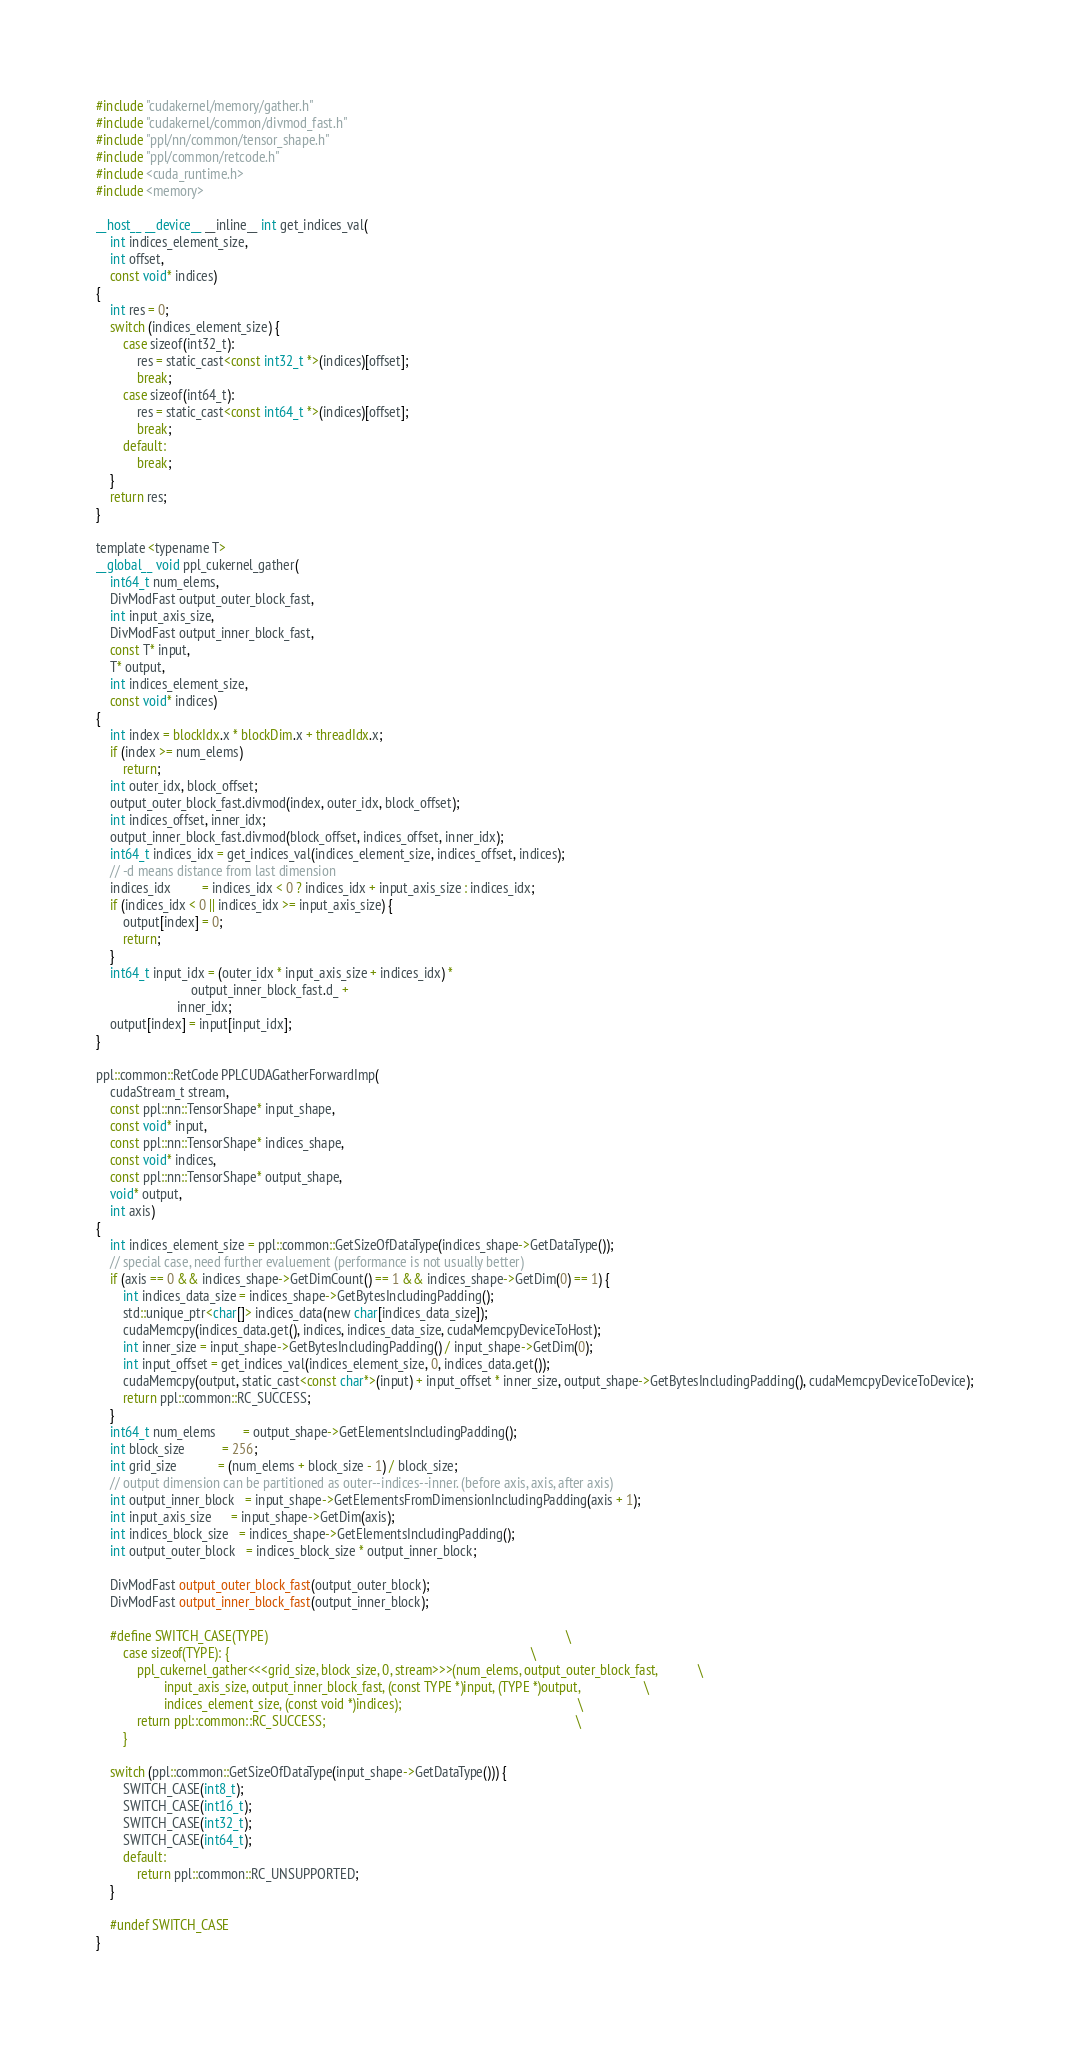<code> <loc_0><loc_0><loc_500><loc_500><_Cuda_>#include "cudakernel/memory/gather.h"
#include "cudakernel/common/divmod_fast.h"
#include "ppl/nn/common/tensor_shape.h"
#include "ppl/common/retcode.h"
#include <cuda_runtime.h>
#include <memory>

__host__ __device__ __inline__ int get_indices_val(
    int indices_element_size,
    int offset,
    const void* indices)
{
    int res = 0;
    switch (indices_element_size) {
        case sizeof(int32_t):
            res = static_cast<const int32_t *>(indices)[offset];
            break;
        case sizeof(int64_t):
            res = static_cast<const int64_t *>(indices)[offset];
            break;
        default:
            break;
    }
    return res;
}

template <typename T>
__global__ void ppl_cukernel_gather(
    int64_t num_elems,
    DivModFast output_outer_block_fast,
    int input_axis_size,
    DivModFast output_inner_block_fast,
    const T* input,
    T* output,
    int indices_element_size,
    const void* indices)
{
    int index = blockIdx.x * blockDim.x + threadIdx.x;
    if (index >= num_elems)
        return;
    int outer_idx, block_offset;
    output_outer_block_fast.divmod(index, outer_idx, block_offset);
    int indices_offset, inner_idx;
    output_inner_block_fast.divmod(block_offset, indices_offset, inner_idx);
    int64_t indices_idx = get_indices_val(indices_element_size, indices_offset, indices);
    // -d means distance from last dimension
    indices_idx         = indices_idx < 0 ? indices_idx + input_axis_size : indices_idx;
    if (indices_idx < 0 || indices_idx >= input_axis_size) {
        output[index] = 0;
        return;
    }
    int64_t input_idx = (outer_idx * input_axis_size + indices_idx) *
                            output_inner_block_fast.d_ +
                        inner_idx;
    output[index] = input[input_idx];
}

ppl::common::RetCode PPLCUDAGatherForwardImp(
    cudaStream_t stream,
    const ppl::nn::TensorShape* input_shape,
    const void* input,
    const ppl::nn::TensorShape* indices_shape,
    const void* indices,
    const ppl::nn::TensorShape* output_shape,
    void* output,
    int axis)
{
    int indices_element_size = ppl::common::GetSizeOfDataType(indices_shape->GetDataType());
    // special case, need further evaluement (performance is not usually better)
    if (axis == 0 && indices_shape->GetDimCount() == 1 && indices_shape->GetDim(0) == 1) {
        int indices_data_size = indices_shape->GetBytesIncludingPadding();
        std::unique_ptr<char[]> indices_data(new char[indices_data_size]);
        cudaMemcpy(indices_data.get(), indices, indices_data_size, cudaMemcpyDeviceToHost);
        int inner_size = input_shape->GetBytesIncludingPadding() / input_shape->GetDim(0);
        int input_offset = get_indices_val(indices_element_size, 0, indices_data.get());
        cudaMemcpy(output, static_cast<const char*>(input) + input_offset * inner_size, output_shape->GetBytesIncludingPadding(), cudaMemcpyDeviceToDevice);
        return ppl::common::RC_SUCCESS;
    }
    int64_t num_elems        = output_shape->GetElementsIncludingPadding();
    int block_size           = 256;
    int grid_size            = (num_elems + block_size - 1) / block_size;
    // output dimension can be partitioned as outer--indices--inner. (before axis, axis, after axis)
    int output_inner_block   = input_shape->GetElementsFromDimensionIncludingPadding(axis + 1);
    int input_axis_size      = input_shape->GetDim(axis);
    int indices_block_size   = indices_shape->GetElementsIncludingPadding();
    int output_outer_block   = indices_block_size * output_inner_block;

    DivModFast output_outer_block_fast(output_outer_block);
    DivModFast output_inner_block_fast(output_inner_block);

    #define SWITCH_CASE(TYPE)                                                                                        \
        case sizeof(TYPE): {                                                                                         \
            ppl_cukernel_gather<<<grid_size, block_size, 0, stream>>>(num_elems, output_outer_block_fast,            \
                    input_axis_size, output_inner_block_fast, (const TYPE *)input, (TYPE *)output,                   \
                    indices_element_size, (const void *)indices);                                                    \
            return ppl::common::RC_SUCCESS;                                                                          \
        }

    switch (ppl::common::GetSizeOfDataType(input_shape->GetDataType())) {
        SWITCH_CASE(int8_t);
        SWITCH_CASE(int16_t);
        SWITCH_CASE(int32_t);
        SWITCH_CASE(int64_t);
        default:
            return ppl::common::RC_UNSUPPORTED;
    }

    #undef SWITCH_CASE
}
</code> 